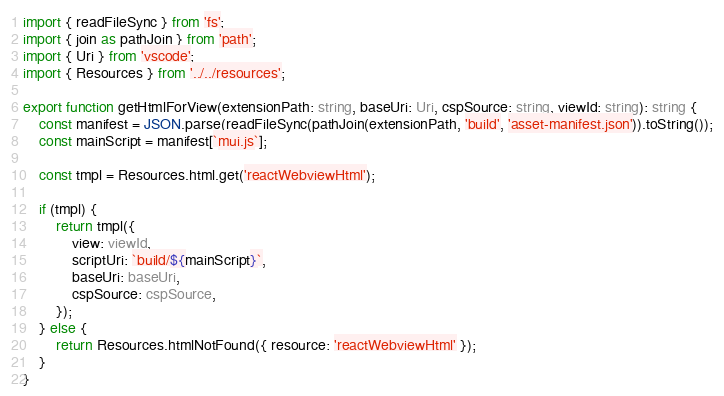Convert code to text. <code><loc_0><loc_0><loc_500><loc_500><_TypeScript_>import { readFileSync } from 'fs';
import { join as pathJoin } from 'path';
import { Uri } from 'vscode';
import { Resources } from '../../resources';

export function getHtmlForView(extensionPath: string, baseUri: Uri, cspSource: string, viewId: string): string {
    const manifest = JSON.parse(readFileSync(pathJoin(extensionPath, 'build', 'asset-manifest.json')).toString());
    const mainScript = manifest[`mui.js`];

    const tmpl = Resources.html.get('reactWebviewHtml');

    if (tmpl) {
        return tmpl({
            view: viewId,
            scriptUri: `build/${mainScript}`,
            baseUri: baseUri,
            cspSource: cspSource,
        });
    } else {
        return Resources.htmlNotFound({ resource: 'reactWebviewHtml' });
    }
}
</code> 